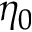Convert formula to latex. <formula><loc_0><loc_0><loc_500><loc_500>\eta _ { 0 }</formula> 